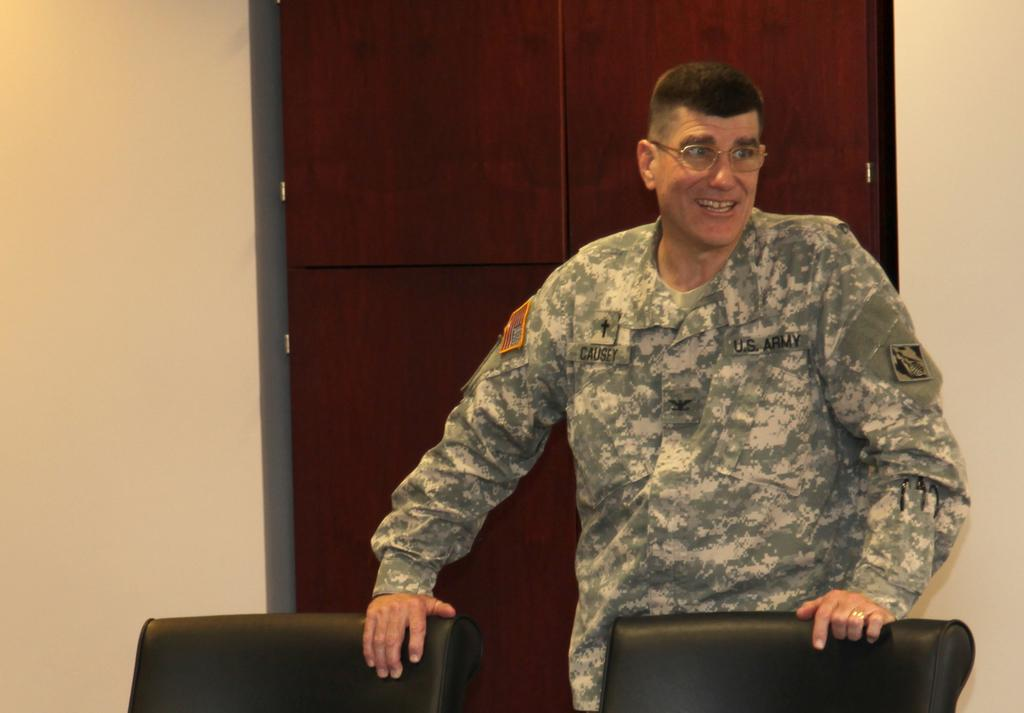What is the main subject of the image? There is a person in the image. Can you describe the person's appearance? The person is wearing specs. What is the person's posture in the image? The person is standing. What type of furniture can be seen in the image? There are chairs in the image. What can be seen in the background of the image? There is a cupboard between the walls in the background. What type of dock can be seen in the image? There is no dock present in the image. How many roses are on the person's lapel in the image? There is no rose mentioned or visible in the image. 